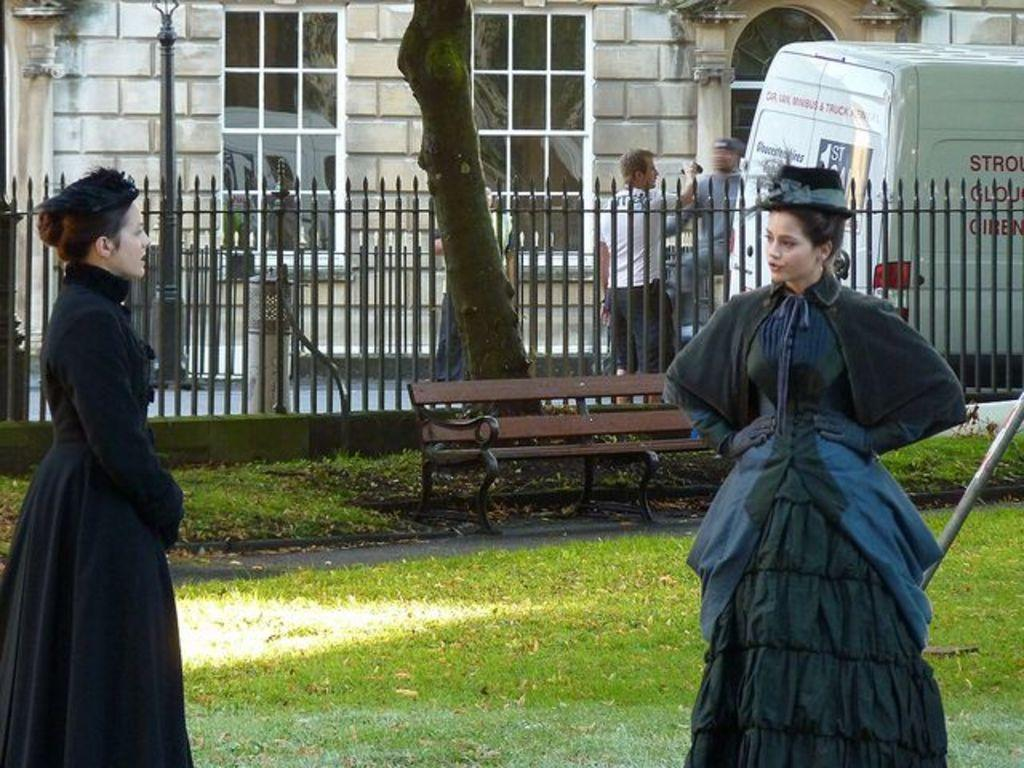What are the two women in the image doing? The two women in the image are standing and speaking to each other. What can be seen in the background of the image? There is a tree, a bench, a building, and a van in the image. What are the two men in the image doing? The two men in the image are standing near the van. What type of coal is being used to heat the building in the image? There is no coal present in the image, nor is there any indication of heating or a coal-burning system. 